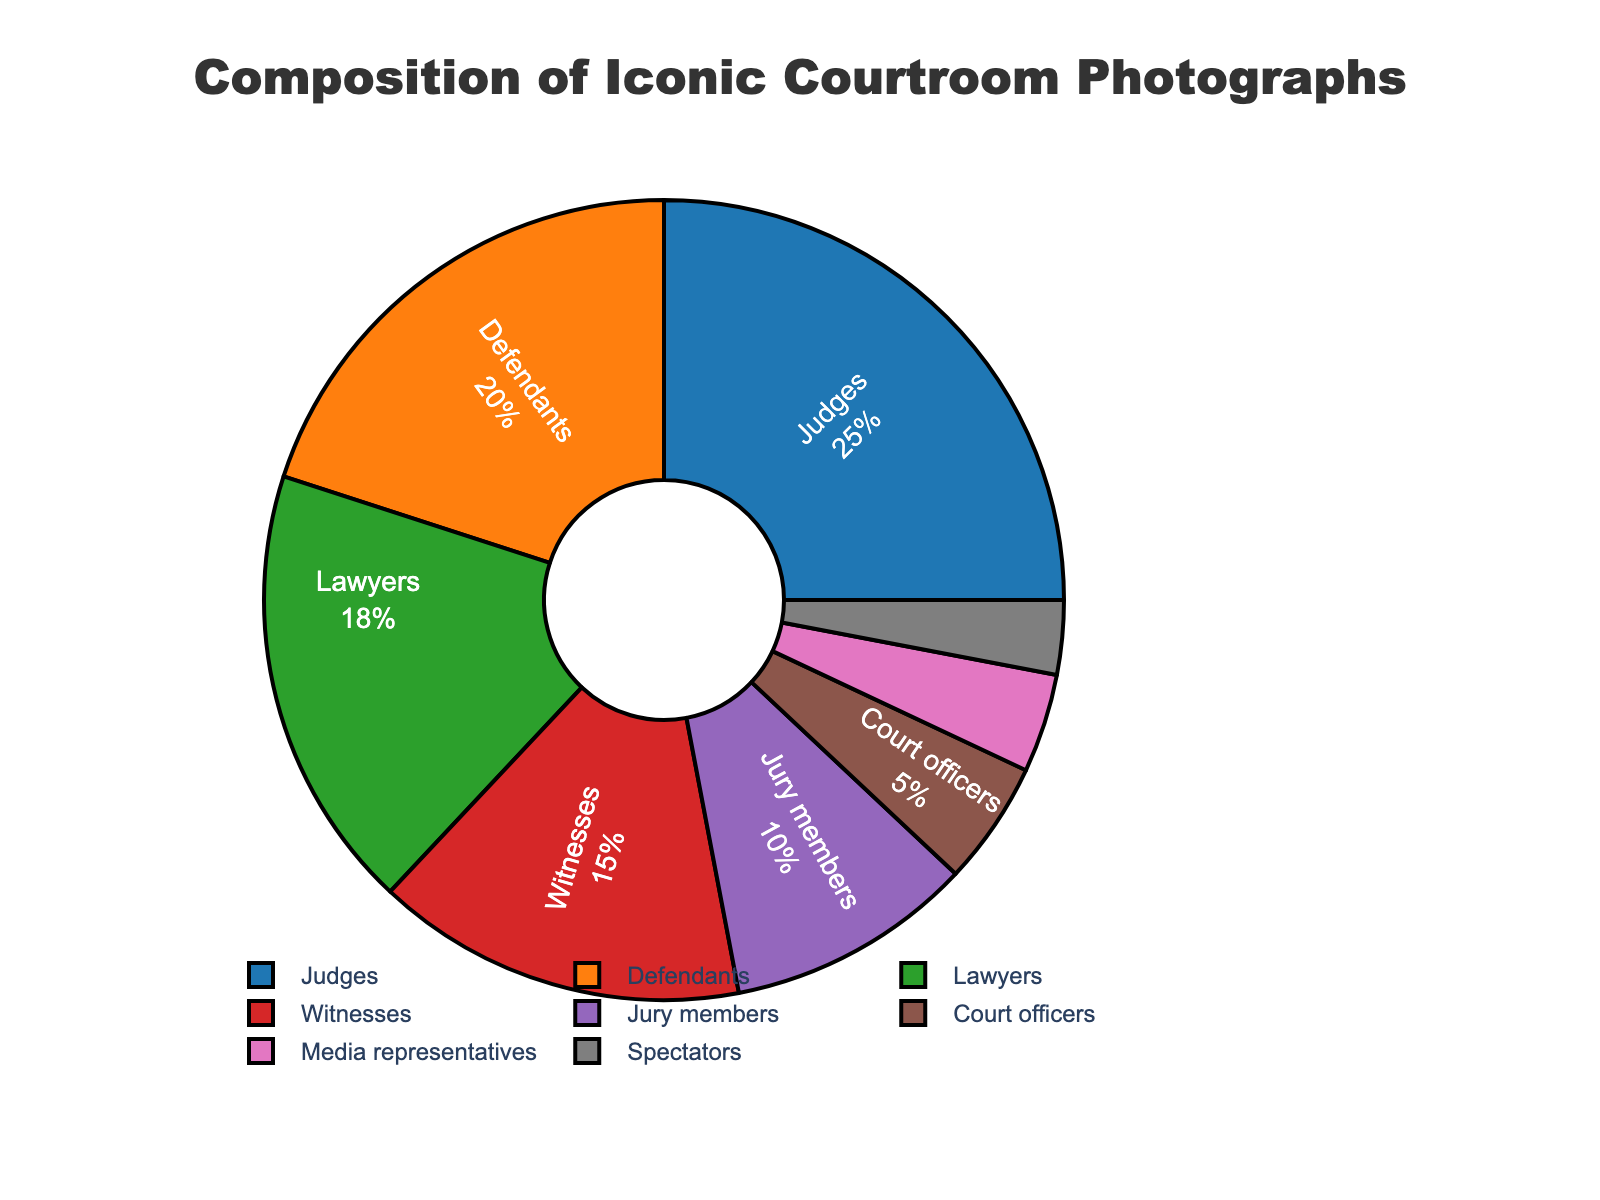What proportion of the subjects are either judges or lawyers? To find the proportion of subjects that are either judges or lawyers, we sum their percentages. The percentage for judges is 25% and for lawyers is 18%. Adding these gives us: 25% + 18% = 43%.
Answer: 43% Which two subject categories have the smallest percentages? To determine the two categories with the smallest percentages, we examine the given percentages: Court officers (5%), Media representatives (4%), and Spectators (3%). The two smallest values are Media representatives and Spectators.
Answer: Media representatives and Spectators How much greater is the percentage of judges compared to witnesses? To find how much greater the percentage of judges is compared to witnesses, we subtract the percentage of witnesses from that of judges. The percentage for judges is 25% and for witnesses is 15%. So, 25% - 15% = 10%.
Answer: 10% What is the combined percentage of jury members, court officers, and media representatives? To find the combined percentage of these three categories, we sum their percentages: Jury members (10%), Court officers (5%), and Media representatives (4%). Adding these gives us: 10% + 5% + 4% = 19%.
Answer: 19% Are there more photographs of defendants or witnesses? From the given percentages, defendants account for 20% while witnesses account for 15%. Since 20% is greater than 15%, there are more photographs of defendants.
Answer: Defendants How many more percentage points do judges make up compared to the total percentage of media representatives and spectators combined? To find the number of percentage points judges make up compared to the combined total of media representatives and spectators, we first add the percentages of Media representatives (4%) and Spectators (3%), which is 4% + 3% = 7%. Then, we subtract this sum from the percentage for judges: 25% - 7% = 18%.
Answer: 18% What is the percentage difference between defendants and lawyers? To find the percentage difference between defendants and lawyers, we subtract the smaller percentage from the larger one. The percentage for defendants is 20% and for lawyers is 18%. So, 20% - 18% = 2%.
Answer: 2% What is the average percentage of judges, defendants, and lawyers? To find the average percentage of judges, defendants, and lawyers, we sum their percentages and then divide by the number of categories. Adding their percentages: 25% + 20% + 18% = 63%. Dividing by 3 gives us: 63% / 3 = 21%.
Answer: 21% Which subject has the largest proportion in the pie chart? The subject with the largest proportion is the one with the highest percentage. From the given data, judges have the highest percentage at 25%.
Answer: Judges 